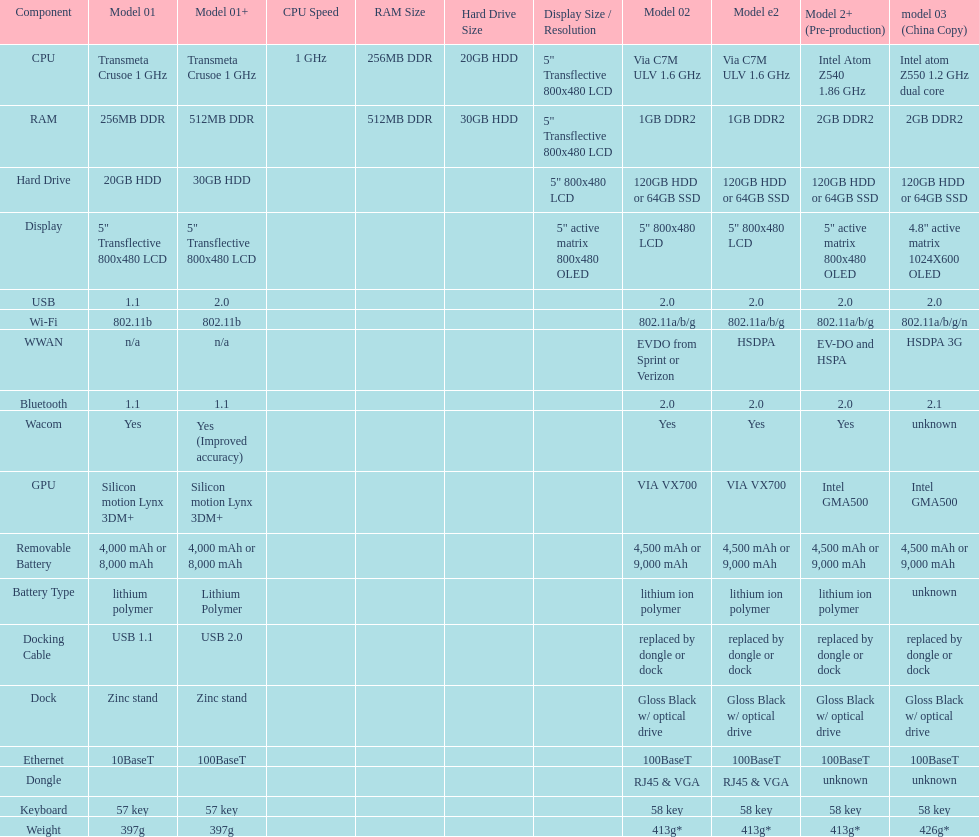How many models use a usb docking cable? 2. 